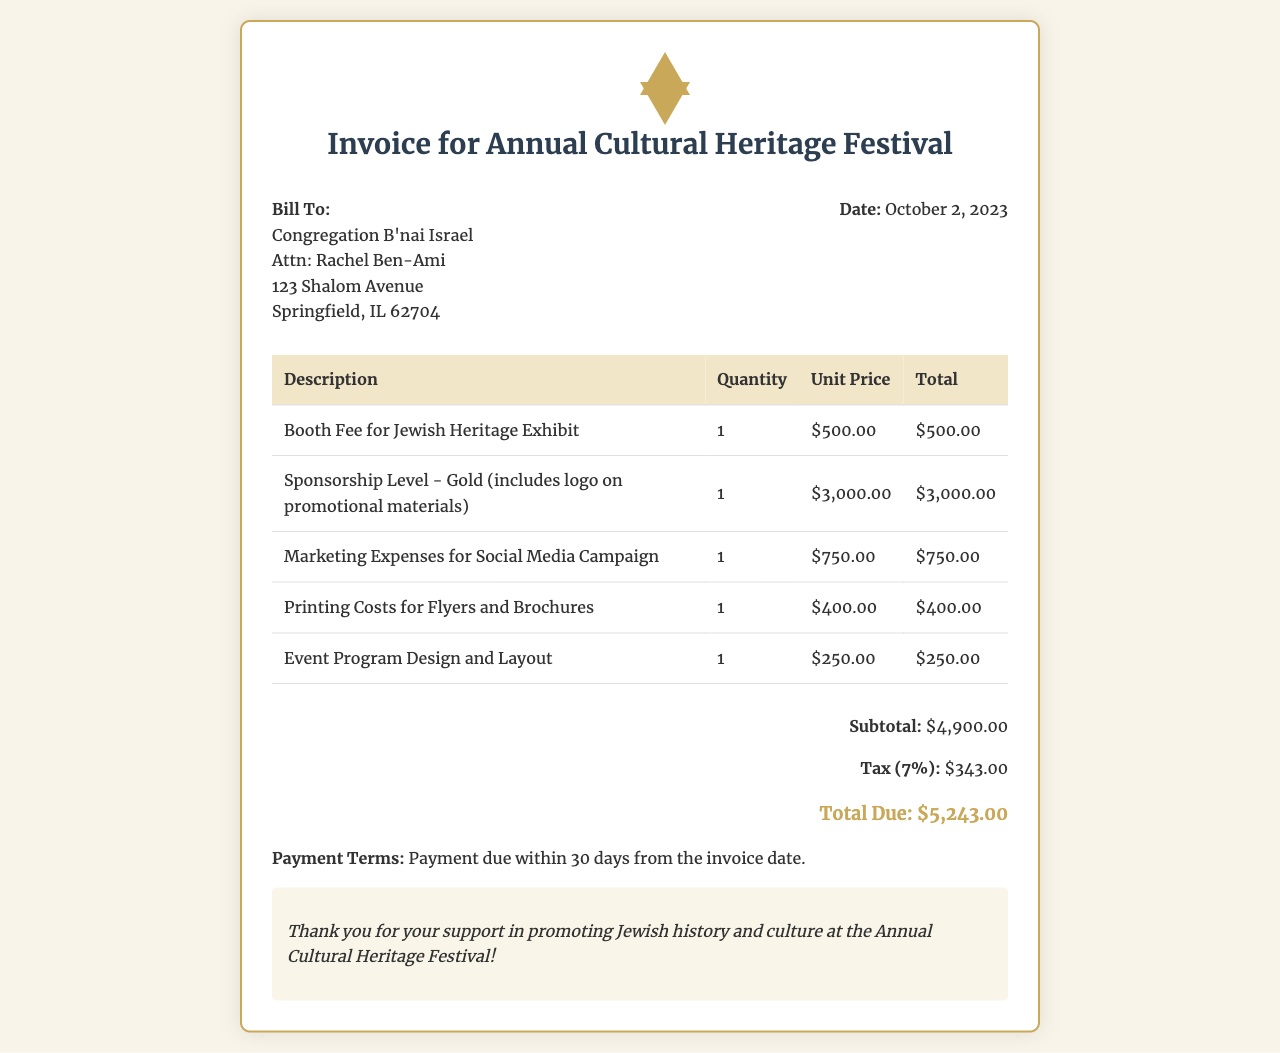What is the date of the invoice? The date of the invoice is presented clearly in the document, indicating when it was issued.
Answer: October 2, 2023 What is included in the Gold sponsorship level? The Gold sponsorship level includes a logo on promotional materials, as stated in the invoice.
Answer: Logo on promotional materials What is the subtotal before tax? The subtotal is the total of all fees before applying tax, which is detailed in the totals section of the invoice.
Answer: $4,900.00 How much is the booth fee for the Jewish Heritage Exhibit? The booth fee is listed specifically in the itemized section of the invoice.
Answer: $500.00 What are the payment terms indicated in the invoice? The payment terms provide guidelines for when payment is due, which are specified at the end of the document.
Answer: Payment due within 30 days from the invoice date What is the total amount due? The total amount due is calculated after including tax in the totals section of the invoice.
Answer: $5,243.00 What percentage is the tax on the invoice? The tax percentage is expressed in the totals section, indicating how much is added to the subtotal.
Answer: 7% What is the total for printing costs for flyers and brochures? The printing costs are itemized in the invoice, providing clarity on each individual cost.
Answer: $400.00 What is mentioned in the notes section of the invoice? The notes section expresses gratitude for support, which is a standard inclusion in such documents.
Answer: Thank you for your support in promoting Jewish history and culture at the Annual Cultural Heritage Festival! 